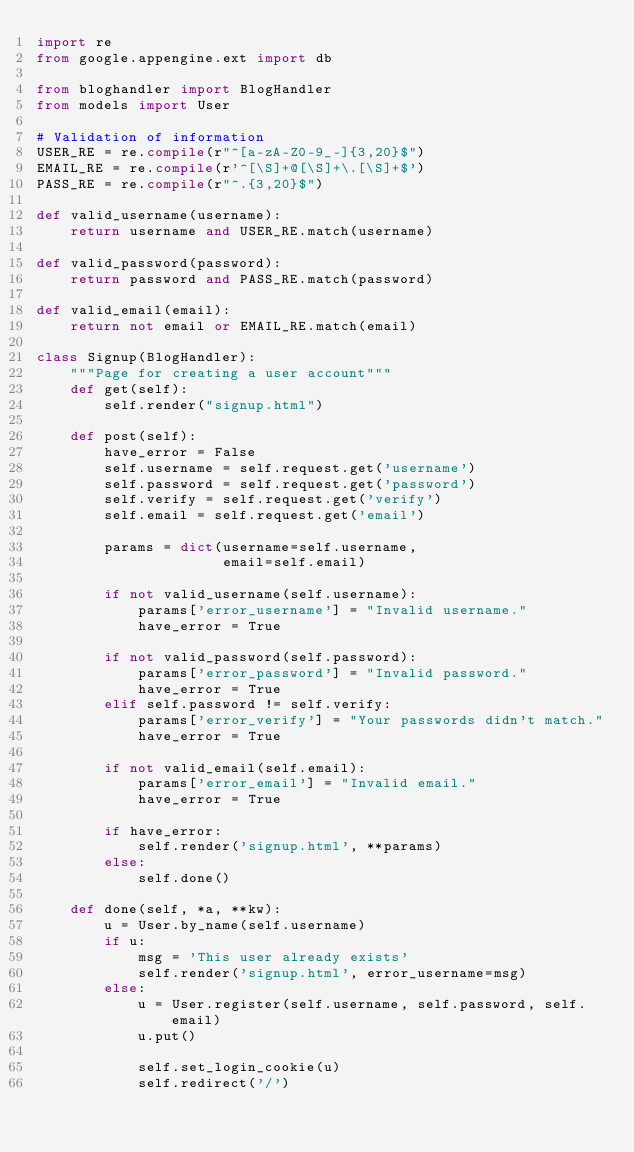Convert code to text. <code><loc_0><loc_0><loc_500><loc_500><_Python_>import re
from google.appengine.ext import db

from bloghandler import BlogHandler
from models import User

# Validation of information
USER_RE = re.compile(r"^[a-zA-Z0-9_-]{3,20}$")
EMAIL_RE = re.compile(r'^[\S]+@[\S]+\.[\S]+$')
PASS_RE = re.compile(r"^.{3,20}$")

def valid_username(username):
    return username and USER_RE.match(username)

def valid_password(password):
    return password and PASS_RE.match(password)

def valid_email(email):
    return not email or EMAIL_RE.match(email)

class Signup(BlogHandler):
    """Page for creating a user account"""
    def get(self):
        self.render("signup.html")

    def post(self):
        have_error = False
        self.username = self.request.get('username')
        self.password = self.request.get('password')
        self.verify = self.request.get('verify')
        self.email = self.request.get('email')

        params = dict(username=self.username,
                      email=self.email)

        if not valid_username(self.username):
            params['error_username'] = "Invalid username."
            have_error = True

        if not valid_password(self.password):
            params['error_password'] = "Invalid password."
            have_error = True
        elif self.password != self.verify:
            params['error_verify'] = "Your passwords didn't match."
            have_error = True

        if not valid_email(self.email):
            params['error_email'] = "Invalid email."
            have_error = True

        if have_error:
            self.render('signup.html', **params)
        else:
            self.done()

    def done(self, *a, **kw):
        u = User.by_name(self.username)
        if u:
            msg = 'This user already exists'
            self.render('signup.html', error_username=msg)
        else:
            u = User.register(self.username, self.password, self.email)
            u.put()

            self.set_login_cookie(u)
            self.redirect('/')
</code> 